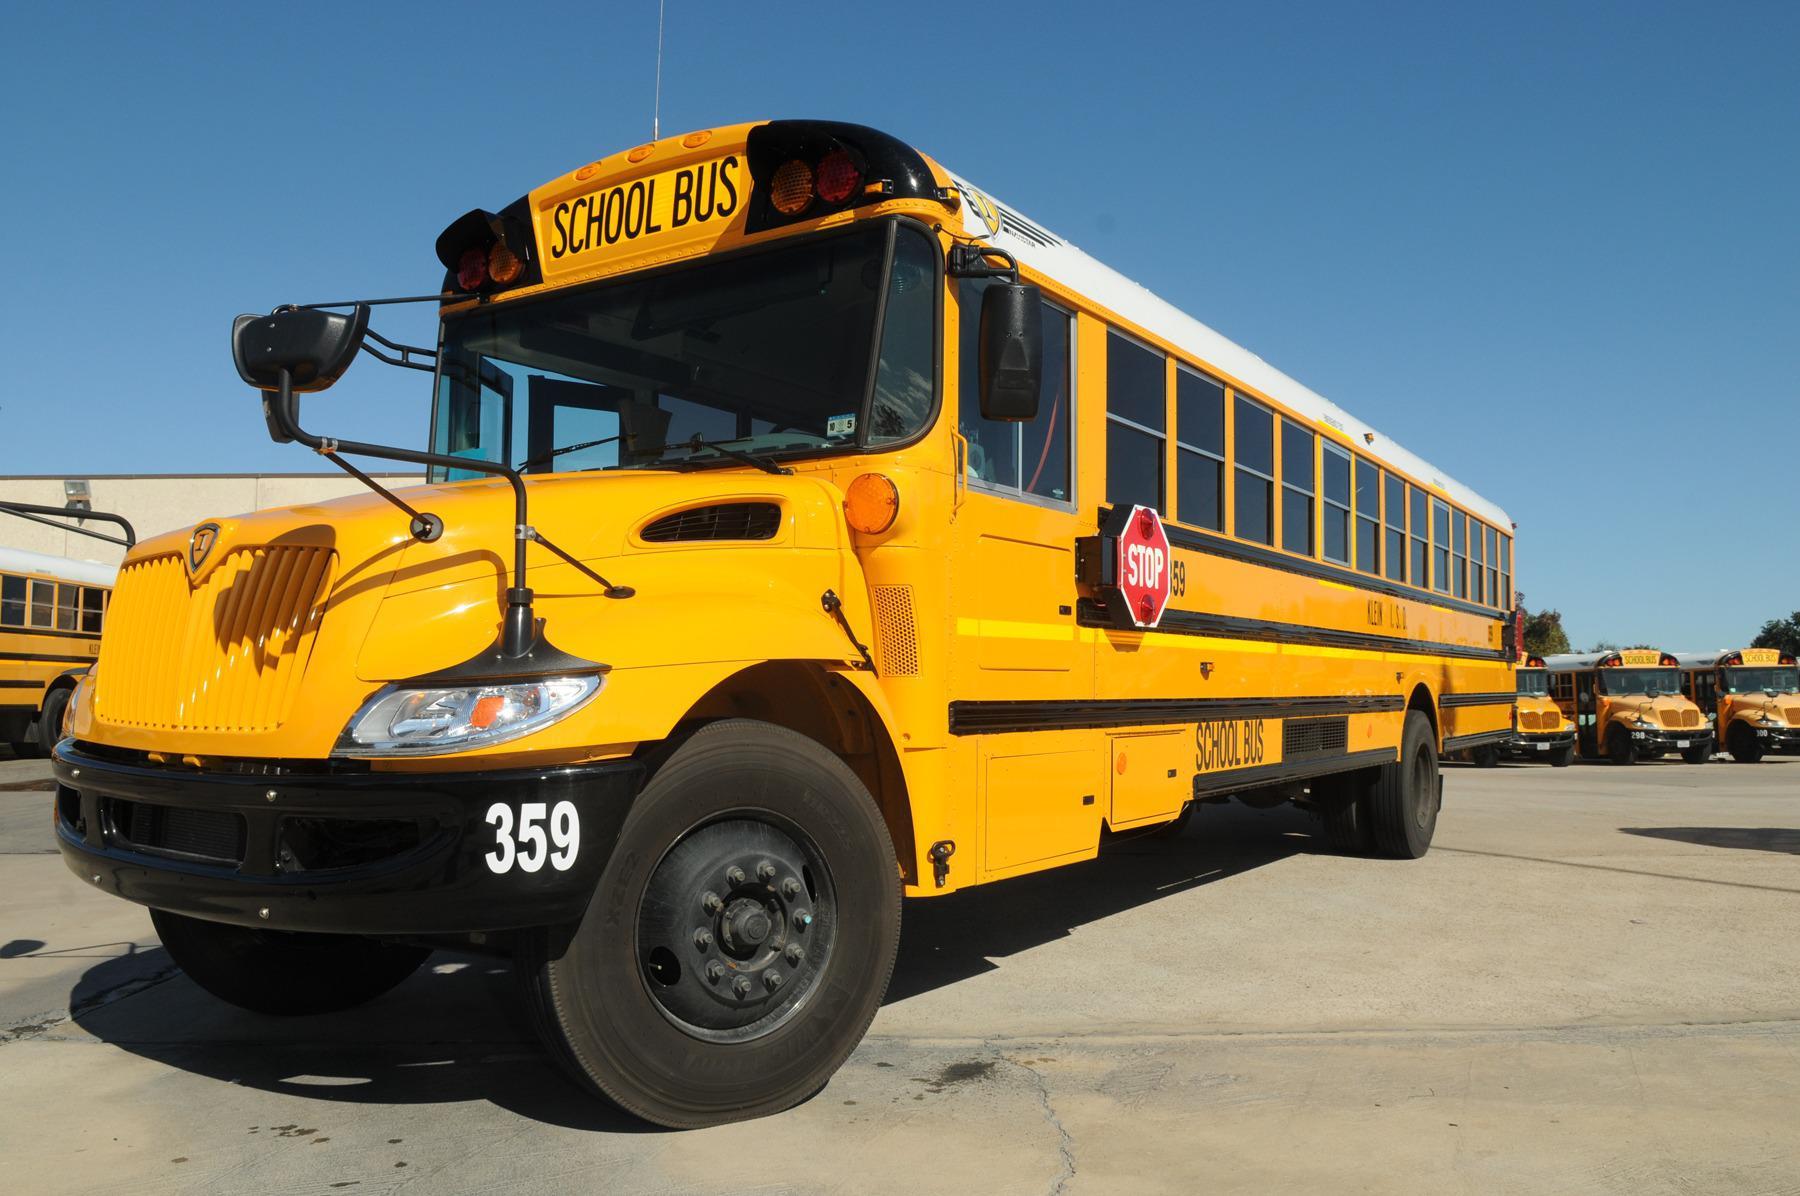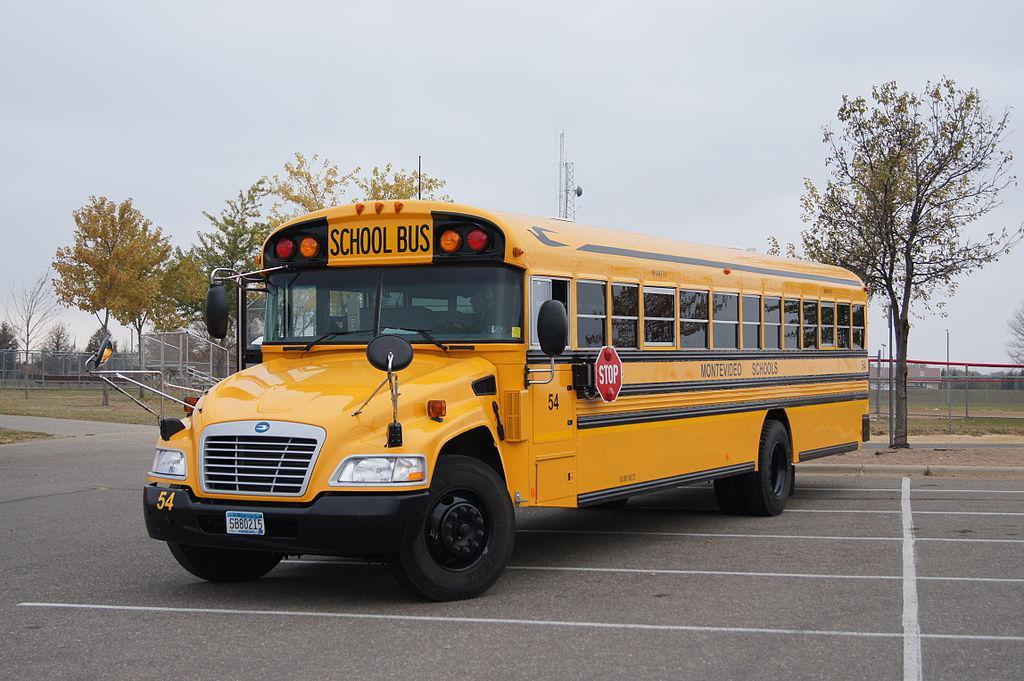The first image is the image on the left, the second image is the image on the right. Assess this claim about the two images: "All school buses are intact and angled heading rightward, with no buildings visible behind them.". Correct or not? Answer yes or no. No. 